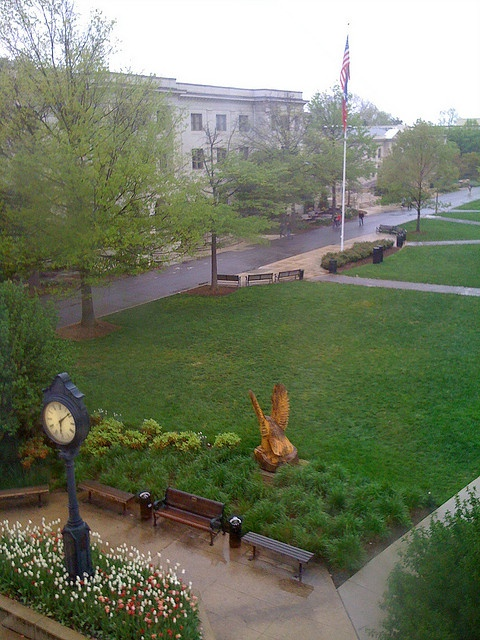Describe the objects in this image and their specific colors. I can see bench in lightgray, black, maroon, and gray tones, clock in lightgray, tan, gray, and black tones, bench in lightgray, gray, and black tones, bench in lightgray, maroon, brown, and black tones, and bench in lightgray, maroon, black, and gray tones in this image. 